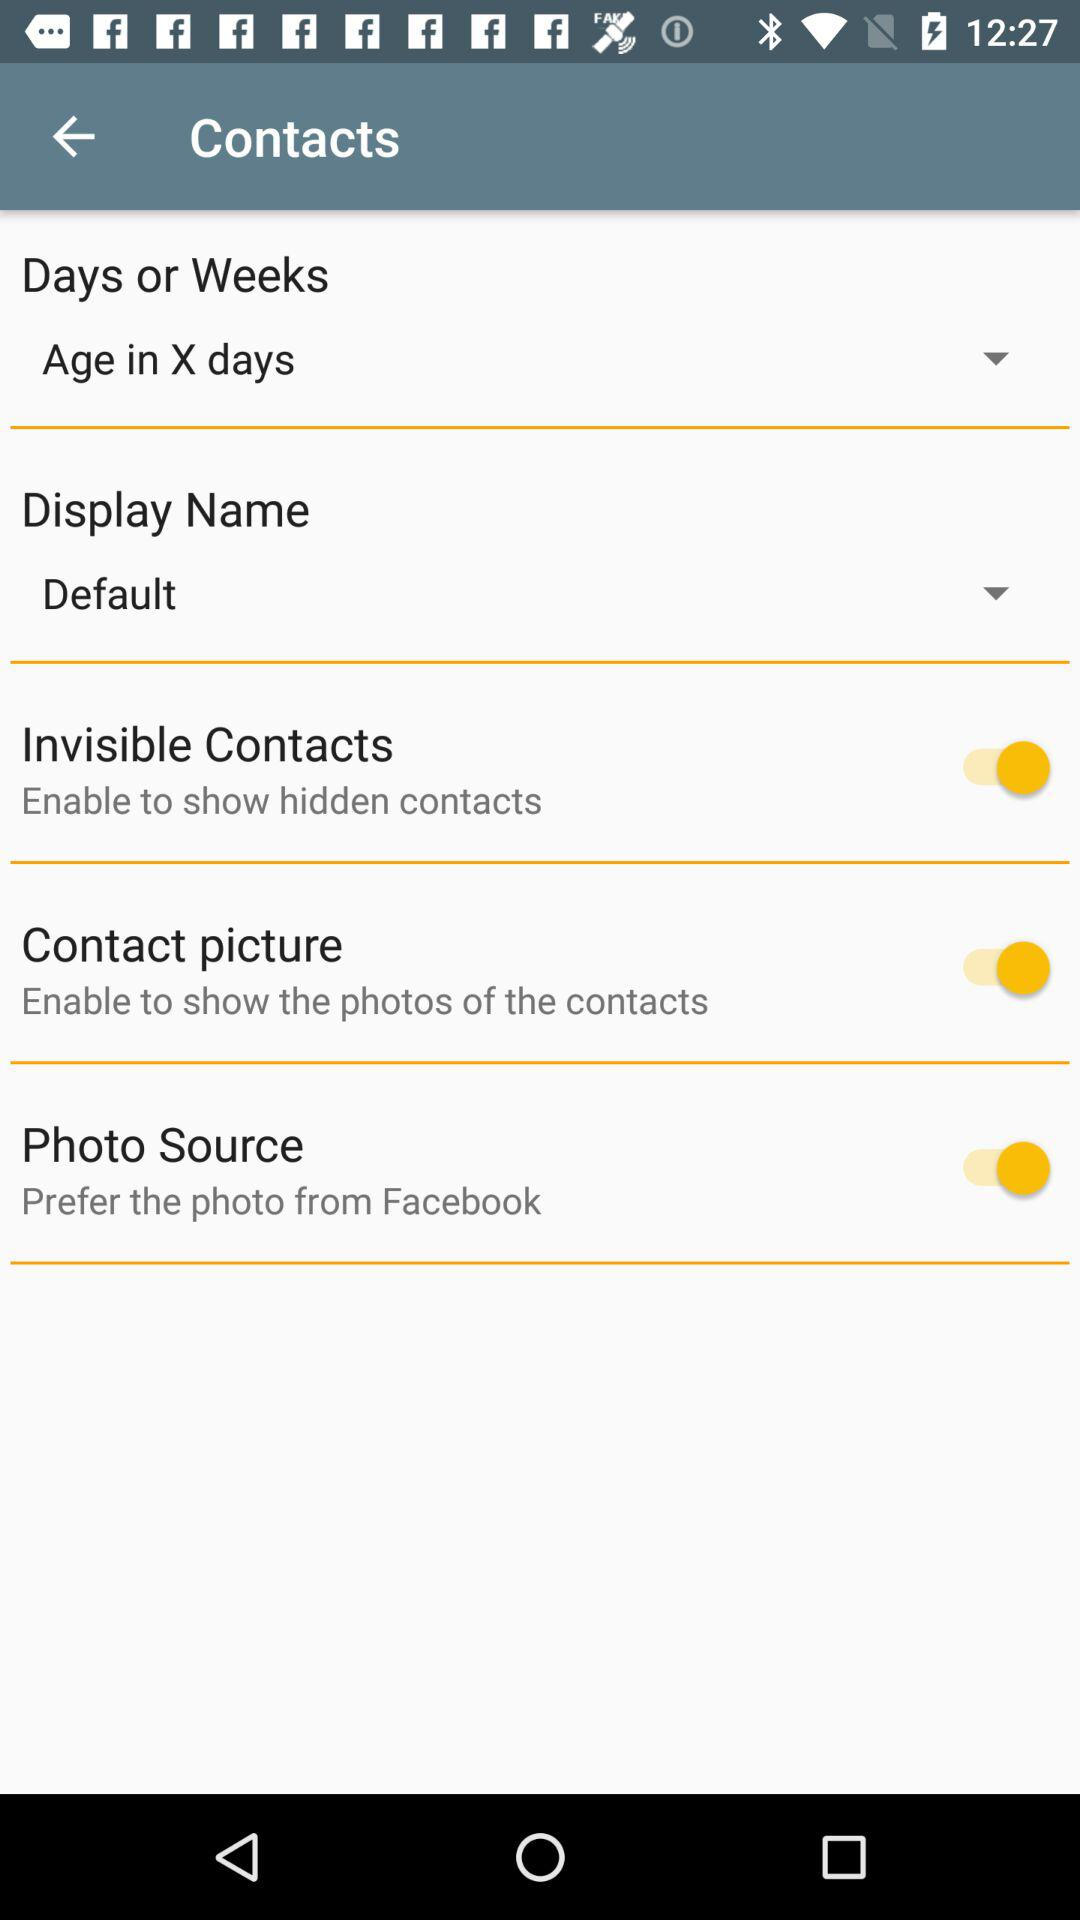What is the status of the "Invisible Contacts"? The status is "on". 